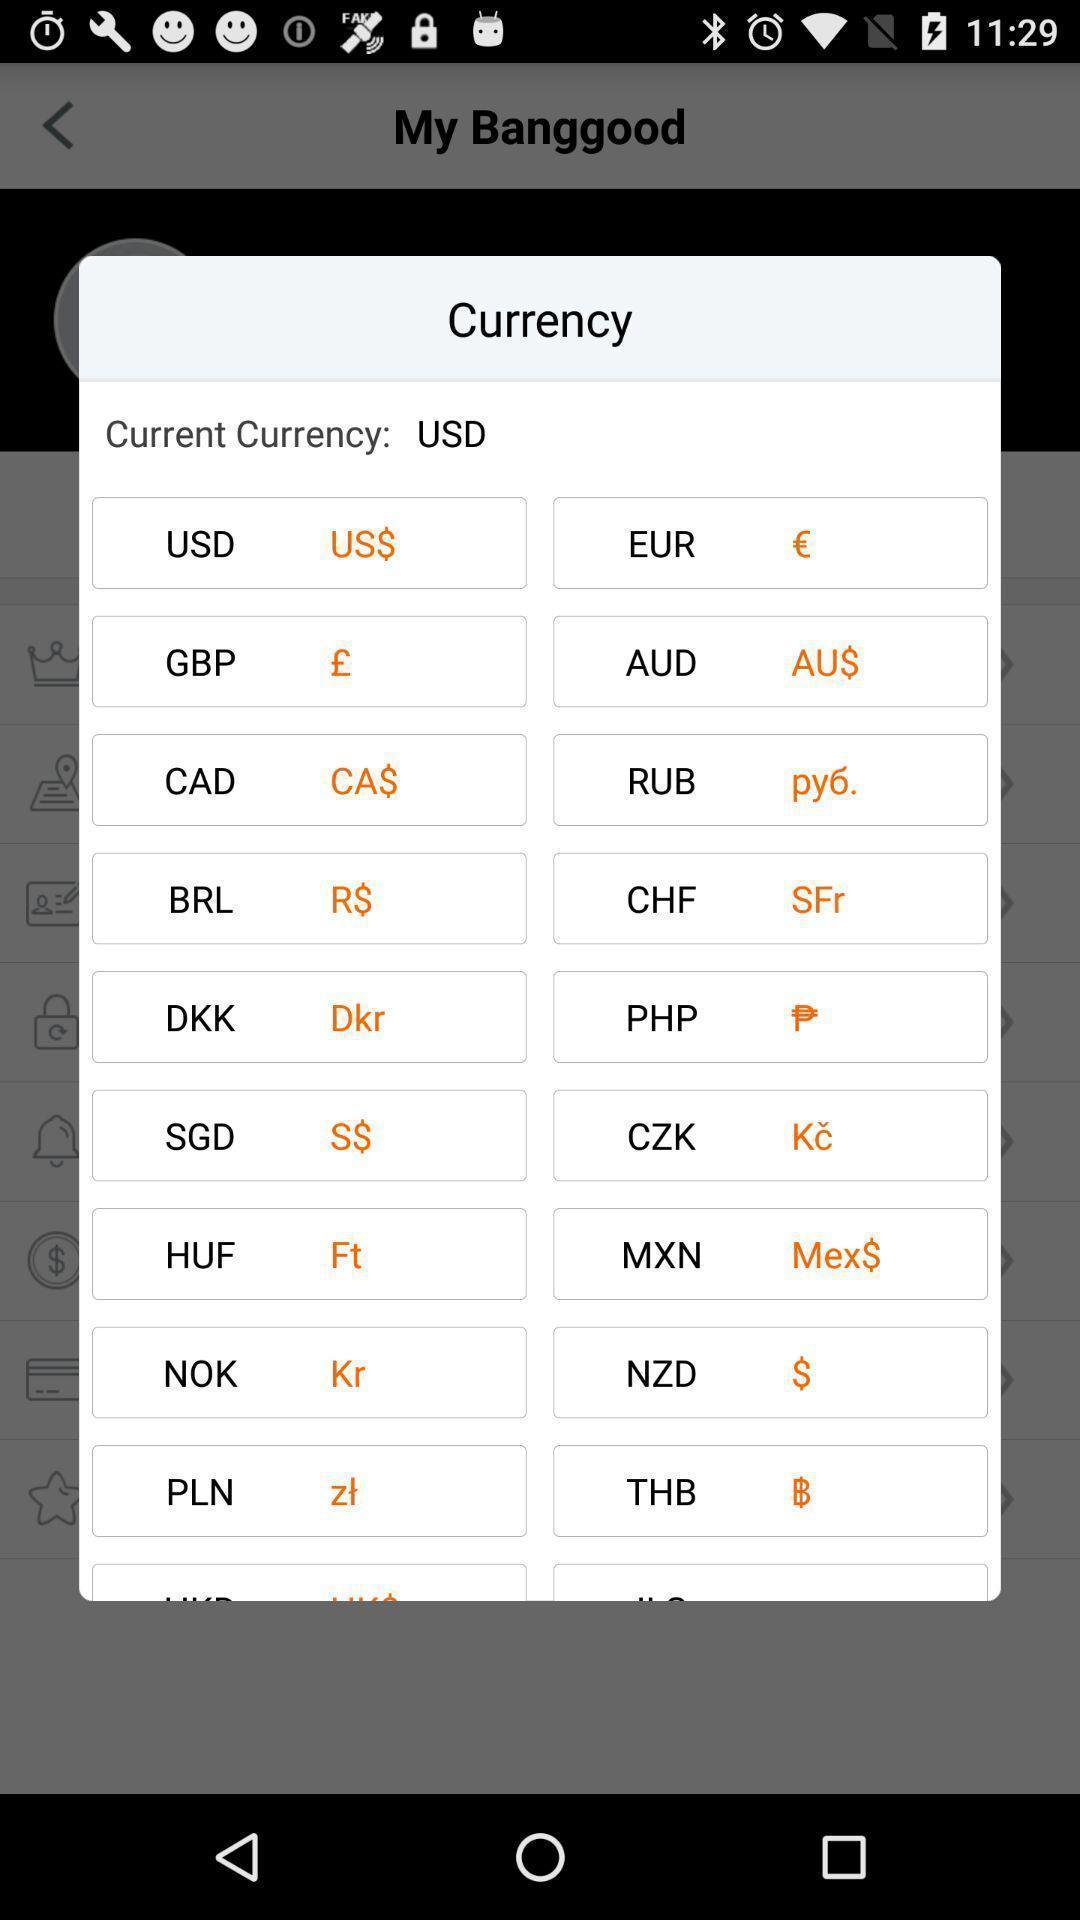Provide a textual representation of this image. Push up displaying list of various currencies. 